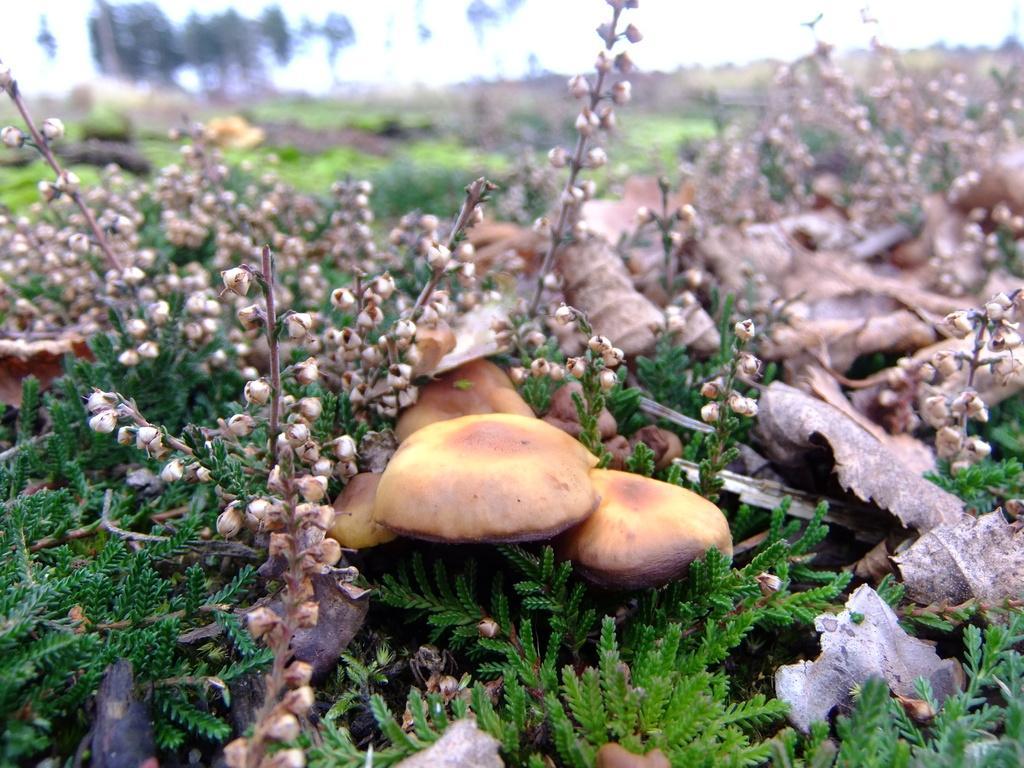Please provide a concise description of this image. In this picture I can observe mushrooms on the ground. I can observe some plants on the ground. The background is blurred. 